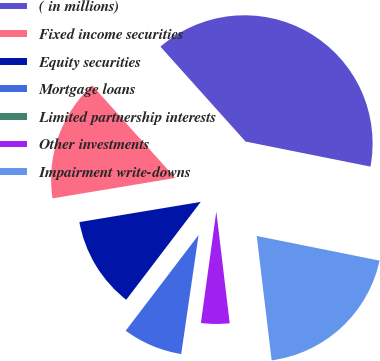Convert chart. <chart><loc_0><loc_0><loc_500><loc_500><pie_chart><fcel>( in millions)<fcel>Fixed income securities<fcel>Equity securities<fcel>Mortgage loans<fcel>Limited partnership interests<fcel>Other investments<fcel>Impairment write-downs<nl><fcel>39.79%<fcel>15.99%<fcel>12.02%<fcel>8.05%<fcel>0.12%<fcel>4.09%<fcel>19.95%<nl></chart> 